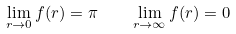<formula> <loc_0><loc_0><loc_500><loc_500>\lim _ { r \rightarrow 0 } f ( r ) = \pi \quad \lim _ { r \rightarrow \infty } f ( r ) = 0</formula> 